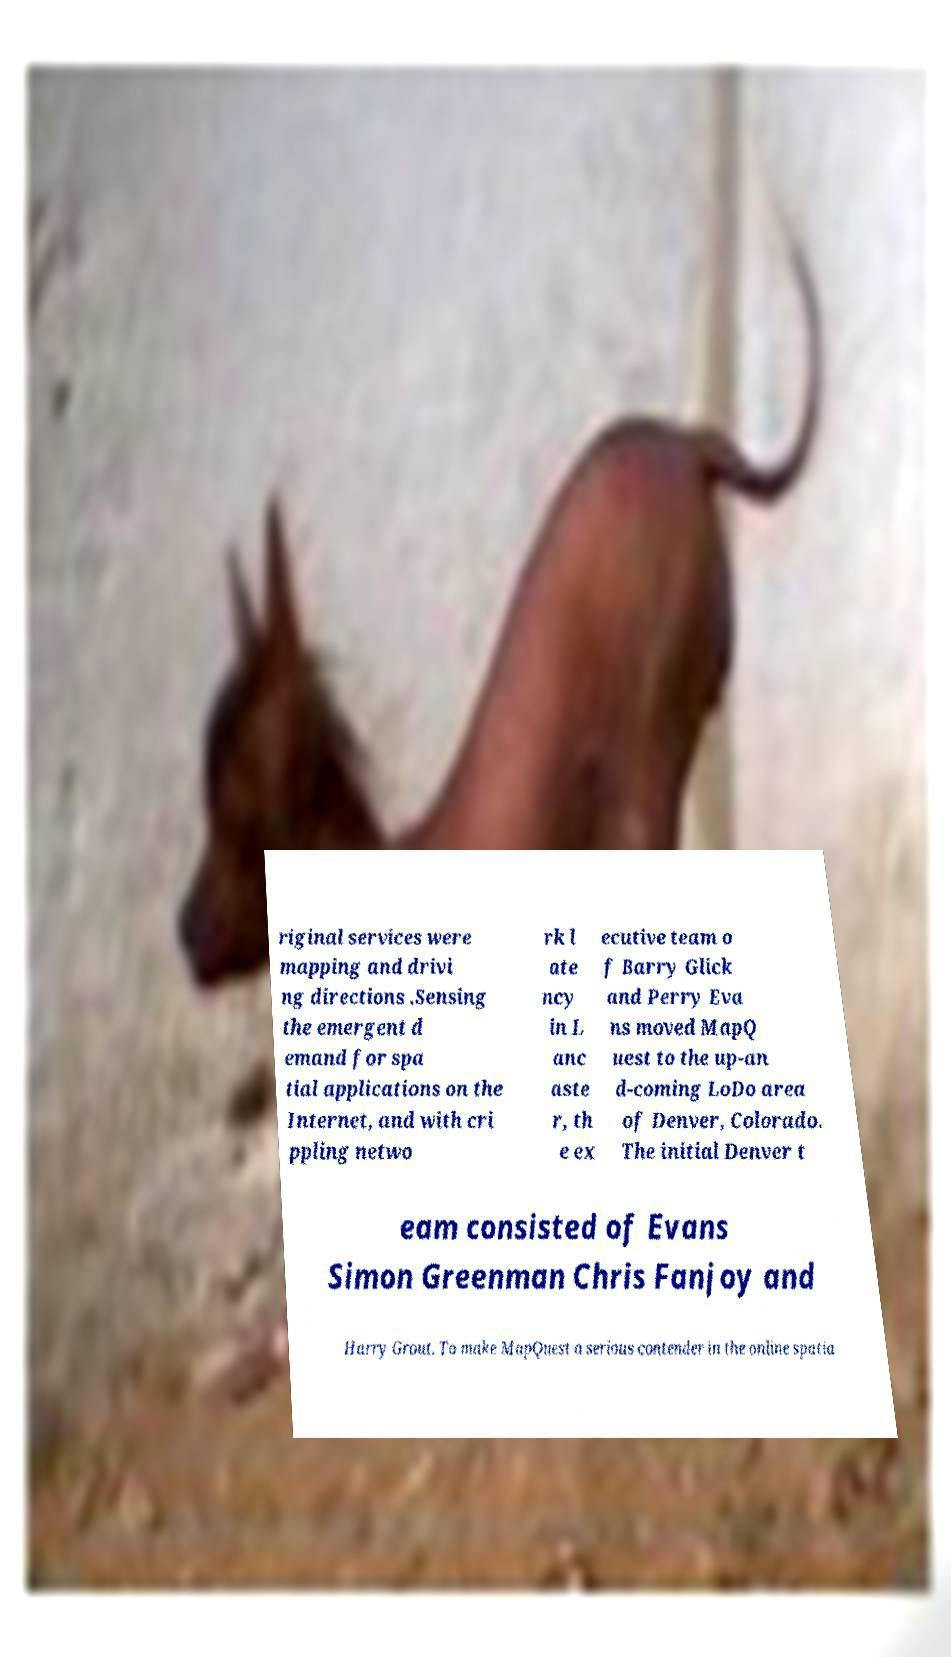Can you accurately transcribe the text from the provided image for me? riginal services were mapping and drivi ng directions .Sensing the emergent d emand for spa tial applications on the Internet, and with cri ppling netwo rk l ate ncy in L anc aste r, th e ex ecutive team o f Barry Glick and Perry Eva ns moved MapQ uest to the up-an d-coming LoDo area of Denver, Colorado. The initial Denver t eam consisted of Evans Simon Greenman Chris Fanjoy and Harry Grout. To make MapQuest a serious contender in the online spatia 